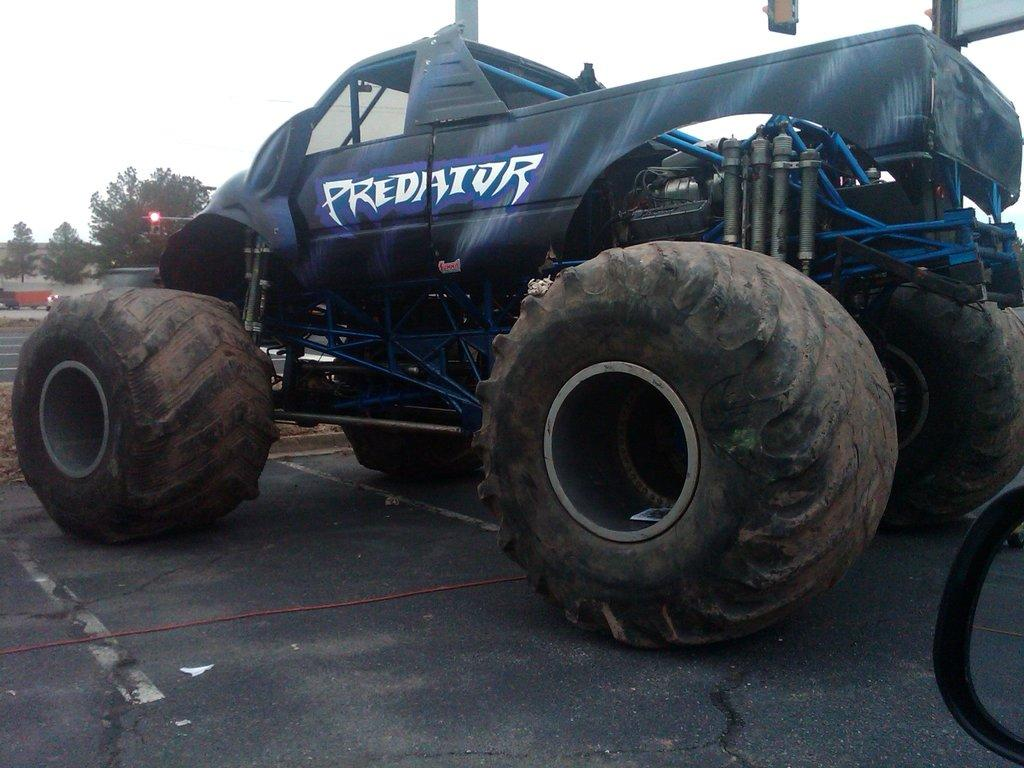What type of vehicle is in the image? There is a truck with huge tires in the image. What can be seen on the truck? The truck has some text on it. What is at the bottom of the image? There is a road at the bottom of the image. What is visible in the background of the image? There are trees and the sky in the background of the image. Can you see a bomb being dropped from the truck in the image? There is no bomb or indication of a bomb being dropped in the image. How many fingers can be seen on the truck driver's hand in the image? There is no truck driver or hand visible in the image. 